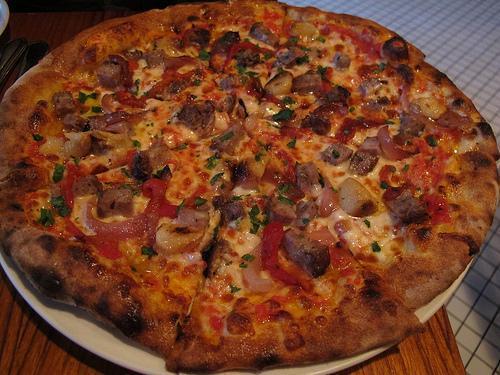How many plates are there?
Give a very brief answer. 1. How many pieces of pizza are sticking out?
Give a very brief answer. 1. How many people are eating food?
Give a very brief answer. 0. 